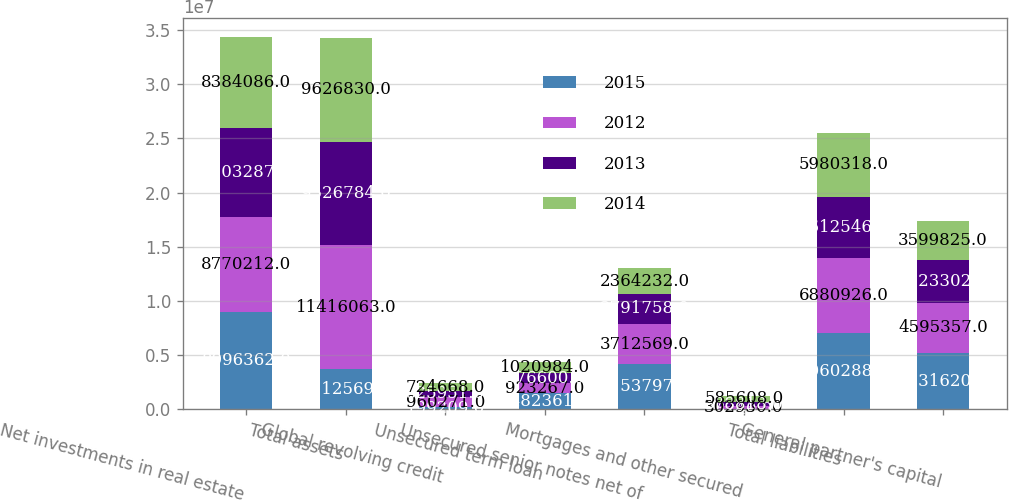<chart> <loc_0><loc_0><loc_500><loc_500><stacked_bar_chart><ecel><fcel>Net investments in real estate<fcel>Total assets<fcel>Global revolving credit<fcel>Unsecured term loan<fcel>Unsecured senior notes net of<fcel>Mortgages and other secured<fcel>Total liabilities<fcel>General partner's capital<nl><fcel>2015<fcel>8.99636e+06<fcel>3.71257e+06<fcel>199209<fcel>1.48236e+06<fcel>4.1538e+06<fcel>3240<fcel>7.06029e+06<fcel>5.23162e+06<nl><fcel>2012<fcel>8.77021e+06<fcel>1.14161e+07<fcel>960271<fcel>923267<fcel>3.71257e+06<fcel>302930<fcel>6.88093e+06<fcel>4.59536e+06<nl><fcel>2013<fcel>8.20329e+06<fcel>9.52678e+06<fcel>525951<fcel>976600<fcel>2.79176e+06<fcel>378818<fcel>5.61255e+06<fcel>3.9233e+06<nl><fcel>2014<fcel>8.38409e+06<fcel>9.62683e+06<fcel>724668<fcel>1.02098e+06<fcel>2.36423e+06<fcel>585608<fcel>5.98032e+06<fcel>3.59982e+06<nl></chart> 